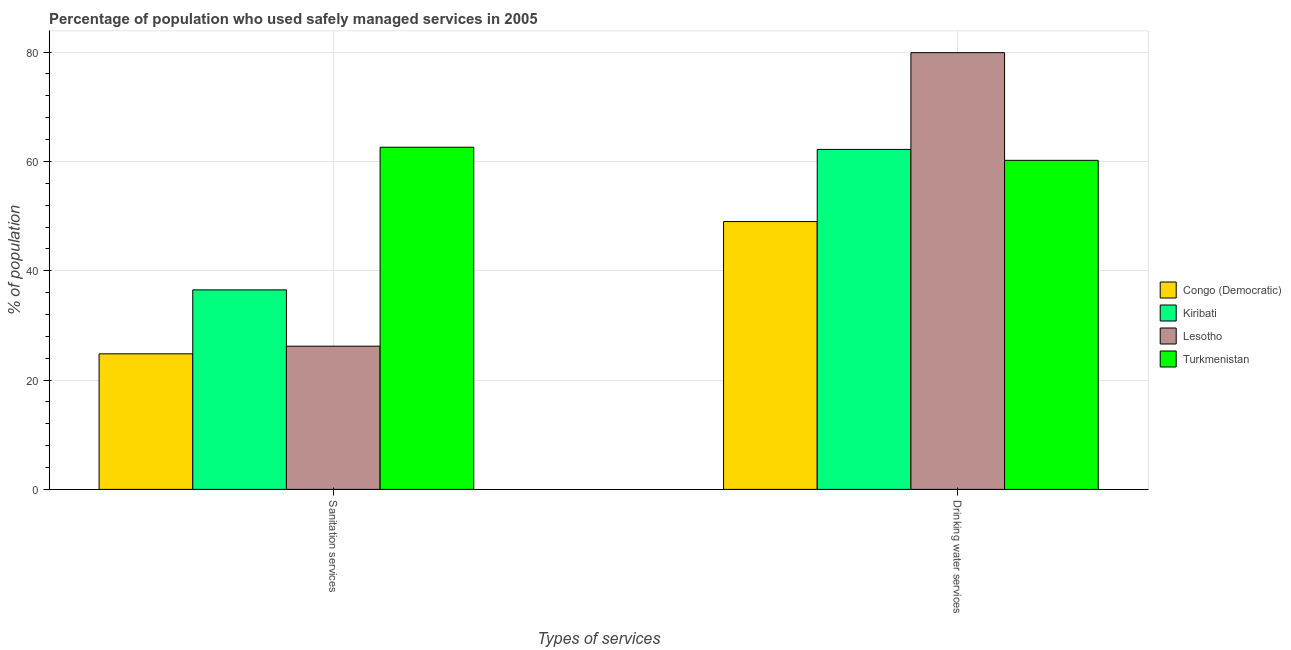How many different coloured bars are there?
Your response must be concise. 4. How many groups of bars are there?
Provide a short and direct response. 2. Are the number of bars per tick equal to the number of legend labels?
Ensure brevity in your answer.  Yes. How many bars are there on the 1st tick from the left?
Offer a terse response. 4. How many bars are there on the 1st tick from the right?
Ensure brevity in your answer.  4. What is the label of the 2nd group of bars from the left?
Provide a succinct answer. Drinking water services. What is the percentage of population who used sanitation services in Lesotho?
Your answer should be compact. 26.2. Across all countries, what is the maximum percentage of population who used sanitation services?
Your answer should be very brief. 62.6. Across all countries, what is the minimum percentage of population who used sanitation services?
Provide a short and direct response. 24.8. In which country was the percentage of population who used sanitation services maximum?
Your answer should be very brief. Turkmenistan. In which country was the percentage of population who used sanitation services minimum?
Provide a succinct answer. Congo (Democratic). What is the total percentage of population who used sanitation services in the graph?
Offer a very short reply. 150.1. What is the difference between the percentage of population who used drinking water services in Congo (Democratic) and that in Kiribati?
Your answer should be very brief. -13.2. What is the difference between the percentage of population who used sanitation services in Kiribati and the percentage of population who used drinking water services in Congo (Democratic)?
Keep it short and to the point. -12.5. What is the average percentage of population who used drinking water services per country?
Provide a succinct answer. 62.83. What is the difference between the percentage of population who used sanitation services and percentage of population who used drinking water services in Congo (Democratic)?
Your answer should be compact. -24.2. In how many countries, is the percentage of population who used sanitation services greater than 48 %?
Your answer should be compact. 1. What is the ratio of the percentage of population who used sanitation services in Kiribati to that in Turkmenistan?
Make the answer very short. 0.58. Is the percentage of population who used drinking water services in Kiribati less than that in Lesotho?
Your answer should be compact. Yes. What does the 4th bar from the left in Sanitation services represents?
Ensure brevity in your answer.  Turkmenistan. What does the 3rd bar from the right in Drinking water services represents?
Your answer should be very brief. Kiribati. How many bars are there?
Your answer should be compact. 8. How many countries are there in the graph?
Provide a succinct answer. 4. What is the difference between two consecutive major ticks on the Y-axis?
Ensure brevity in your answer.  20. Are the values on the major ticks of Y-axis written in scientific E-notation?
Offer a very short reply. No. How many legend labels are there?
Your answer should be compact. 4. How are the legend labels stacked?
Your answer should be very brief. Vertical. What is the title of the graph?
Offer a terse response. Percentage of population who used safely managed services in 2005. Does "Lower middle income" appear as one of the legend labels in the graph?
Make the answer very short. No. What is the label or title of the X-axis?
Keep it short and to the point. Types of services. What is the label or title of the Y-axis?
Provide a short and direct response. % of population. What is the % of population in Congo (Democratic) in Sanitation services?
Provide a succinct answer. 24.8. What is the % of population of Kiribati in Sanitation services?
Give a very brief answer. 36.5. What is the % of population in Lesotho in Sanitation services?
Your answer should be very brief. 26.2. What is the % of population of Turkmenistan in Sanitation services?
Provide a short and direct response. 62.6. What is the % of population of Kiribati in Drinking water services?
Keep it short and to the point. 62.2. What is the % of population in Lesotho in Drinking water services?
Offer a terse response. 79.9. What is the % of population in Turkmenistan in Drinking water services?
Offer a terse response. 60.2. Across all Types of services, what is the maximum % of population of Kiribati?
Give a very brief answer. 62.2. Across all Types of services, what is the maximum % of population of Lesotho?
Keep it short and to the point. 79.9. Across all Types of services, what is the maximum % of population in Turkmenistan?
Your response must be concise. 62.6. Across all Types of services, what is the minimum % of population of Congo (Democratic)?
Provide a succinct answer. 24.8. Across all Types of services, what is the minimum % of population in Kiribati?
Offer a terse response. 36.5. Across all Types of services, what is the minimum % of population of Lesotho?
Give a very brief answer. 26.2. Across all Types of services, what is the minimum % of population in Turkmenistan?
Ensure brevity in your answer.  60.2. What is the total % of population in Congo (Democratic) in the graph?
Provide a succinct answer. 73.8. What is the total % of population of Kiribati in the graph?
Keep it short and to the point. 98.7. What is the total % of population of Lesotho in the graph?
Your answer should be very brief. 106.1. What is the total % of population of Turkmenistan in the graph?
Provide a succinct answer. 122.8. What is the difference between the % of population of Congo (Democratic) in Sanitation services and that in Drinking water services?
Offer a very short reply. -24.2. What is the difference between the % of population in Kiribati in Sanitation services and that in Drinking water services?
Your response must be concise. -25.7. What is the difference between the % of population of Lesotho in Sanitation services and that in Drinking water services?
Offer a very short reply. -53.7. What is the difference between the % of population in Turkmenistan in Sanitation services and that in Drinking water services?
Offer a very short reply. 2.4. What is the difference between the % of population in Congo (Democratic) in Sanitation services and the % of population in Kiribati in Drinking water services?
Keep it short and to the point. -37.4. What is the difference between the % of population of Congo (Democratic) in Sanitation services and the % of population of Lesotho in Drinking water services?
Offer a very short reply. -55.1. What is the difference between the % of population of Congo (Democratic) in Sanitation services and the % of population of Turkmenistan in Drinking water services?
Your answer should be very brief. -35.4. What is the difference between the % of population in Kiribati in Sanitation services and the % of population in Lesotho in Drinking water services?
Provide a succinct answer. -43.4. What is the difference between the % of population of Kiribati in Sanitation services and the % of population of Turkmenistan in Drinking water services?
Offer a terse response. -23.7. What is the difference between the % of population in Lesotho in Sanitation services and the % of population in Turkmenistan in Drinking water services?
Provide a succinct answer. -34. What is the average % of population in Congo (Democratic) per Types of services?
Give a very brief answer. 36.9. What is the average % of population of Kiribati per Types of services?
Your answer should be compact. 49.35. What is the average % of population in Lesotho per Types of services?
Your response must be concise. 53.05. What is the average % of population of Turkmenistan per Types of services?
Give a very brief answer. 61.4. What is the difference between the % of population of Congo (Democratic) and % of population of Lesotho in Sanitation services?
Provide a short and direct response. -1.4. What is the difference between the % of population in Congo (Democratic) and % of population in Turkmenistan in Sanitation services?
Provide a short and direct response. -37.8. What is the difference between the % of population of Kiribati and % of population of Turkmenistan in Sanitation services?
Ensure brevity in your answer.  -26.1. What is the difference between the % of population in Lesotho and % of population in Turkmenistan in Sanitation services?
Your response must be concise. -36.4. What is the difference between the % of population in Congo (Democratic) and % of population in Kiribati in Drinking water services?
Offer a very short reply. -13.2. What is the difference between the % of population in Congo (Democratic) and % of population in Lesotho in Drinking water services?
Provide a succinct answer. -30.9. What is the difference between the % of population in Congo (Democratic) and % of population in Turkmenistan in Drinking water services?
Your answer should be compact. -11.2. What is the difference between the % of population in Kiribati and % of population in Lesotho in Drinking water services?
Give a very brief answer. -17.7. What is the difference between the % of population in Lesotho and % of population in Turkmenistan in Drinking water services?
Ensure brevity in your answer.  19.7. What is the ratio of the % of population of Congo (Democratic) in Sanitation services to that in Drinking water services?
Your response must be concise. 0.51. What is the ratio of the % of population in Kiribati in Sanitation services to that in Drinking water services?
Offer a terse response. 0.59. What is the ratio of the % of population of Lesotho in Sanitation services to that in Drinking water services?
Ensure brevity in your answer.  0.33. What is the ratio of the % of population of Turkmenistan in Sanitation services to that in Drinking water services?
Provide a short and direct response. 1.04. What is the difference between the highest and the second highest % of population of Congo (Democratic)?
Keep it short and to the point. 24.2. What is the difference between the highest and the second highest % of population in Kiribati?
Give a very brief answer. 25.7. What is the difference between the highest and the second highest % of population of Lesotho?
Ensure brevity in your answer.  53.7. What is the difference between the highest and the lowest % of population of Congo (Democratic)?
Make the answer very short. 24.2. What is the difference between the highest and the lowest % of population of Kiribati?
Keep it short and to the point. 25.7. What is the difference between the highest and the lowest % of population of Lesotho?
Offer a terse response. 53.7. 